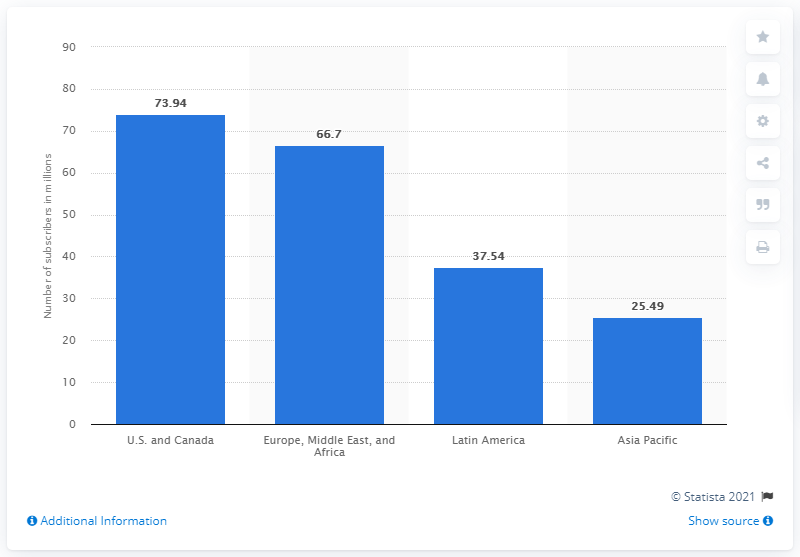Give some essential details in this illustration. In 2020, Netflix had a total of 73,940 paying subscribers in the United States and Canada. 